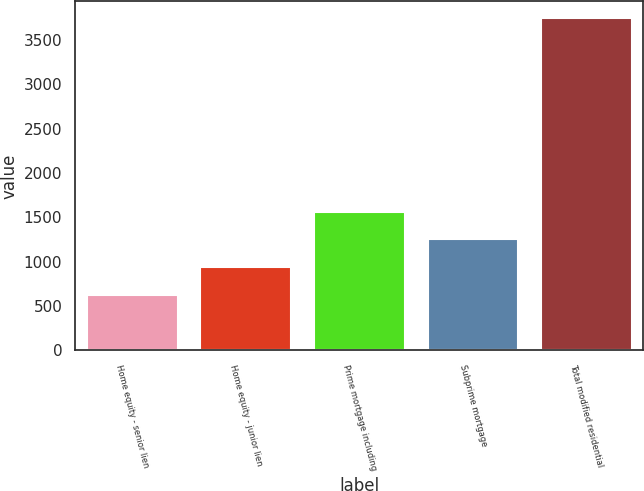<chart> <loc_0><loc_0><loc_500><loc_500><bar_chart><fcel>Home equity - senior lien<fcel>Home equity - junior lien<fcel>Prime mortgage including<fcel>Subprime mortgage<fcel>Total modified residential<nl><fcel>628<fcel>940.2<fcel>1564.6<fcel>1252.4<fcel>3750<nl></chart> 